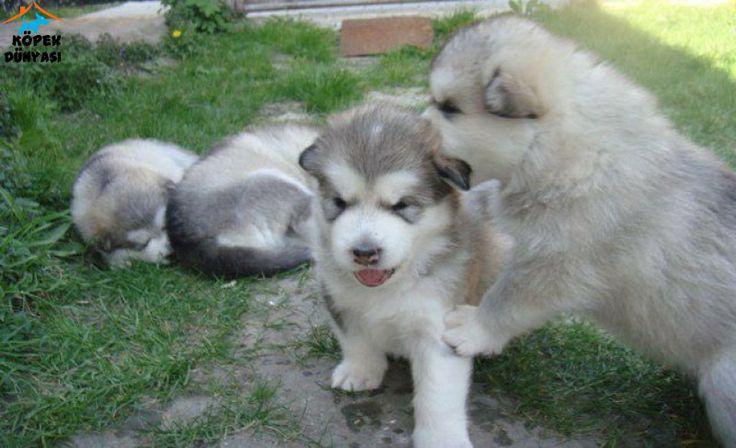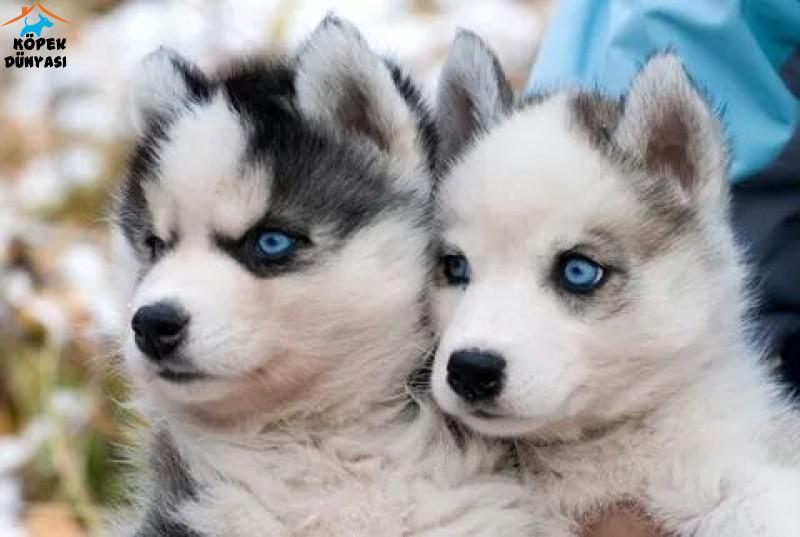The first image is the image on the left, the second image is the image on the right. Examine the images to the left and right. Is the description "There are exactly two dogs." accurate? Answer yes or no. No. The first image is the image on the left, the second image is the image on the right. Evaluate the accuracy of this statement regarding the images: "There are no more than 2 dogs.". Is it true? Answer yes or no. No. 